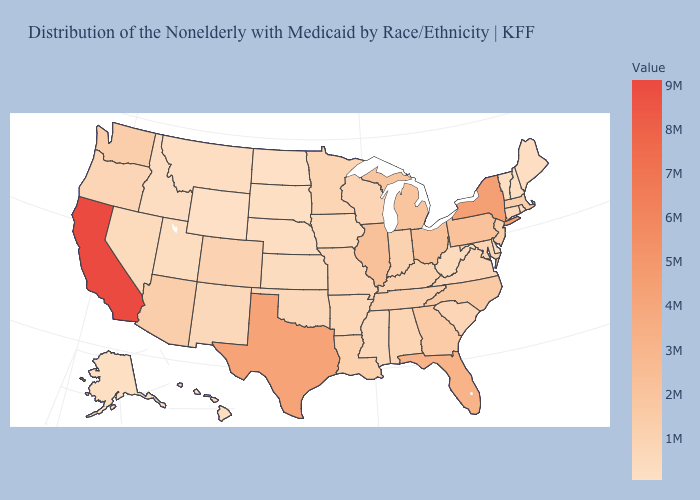Among the states that border Washington , does Idaho have the highest value?
Answer briefly. No. Which states have the lowest value in the USA?
Concise answer only. Wyoming. Among the states that border Ohio , which have the highest value?
Give a very brief answer. Pennsylvania. Among the states that border Florida , does Georgia have the highest value?
Give a very brief answer. Yes. Which states hav the highest value in the South?
Concise answer only. Texas. Does New York have the highest value in the USA?
Answer briefly. No. Is the legend a continuous bar?
Quick response, please. Yes. Does the map have missing data?
Answer briefly. No. 